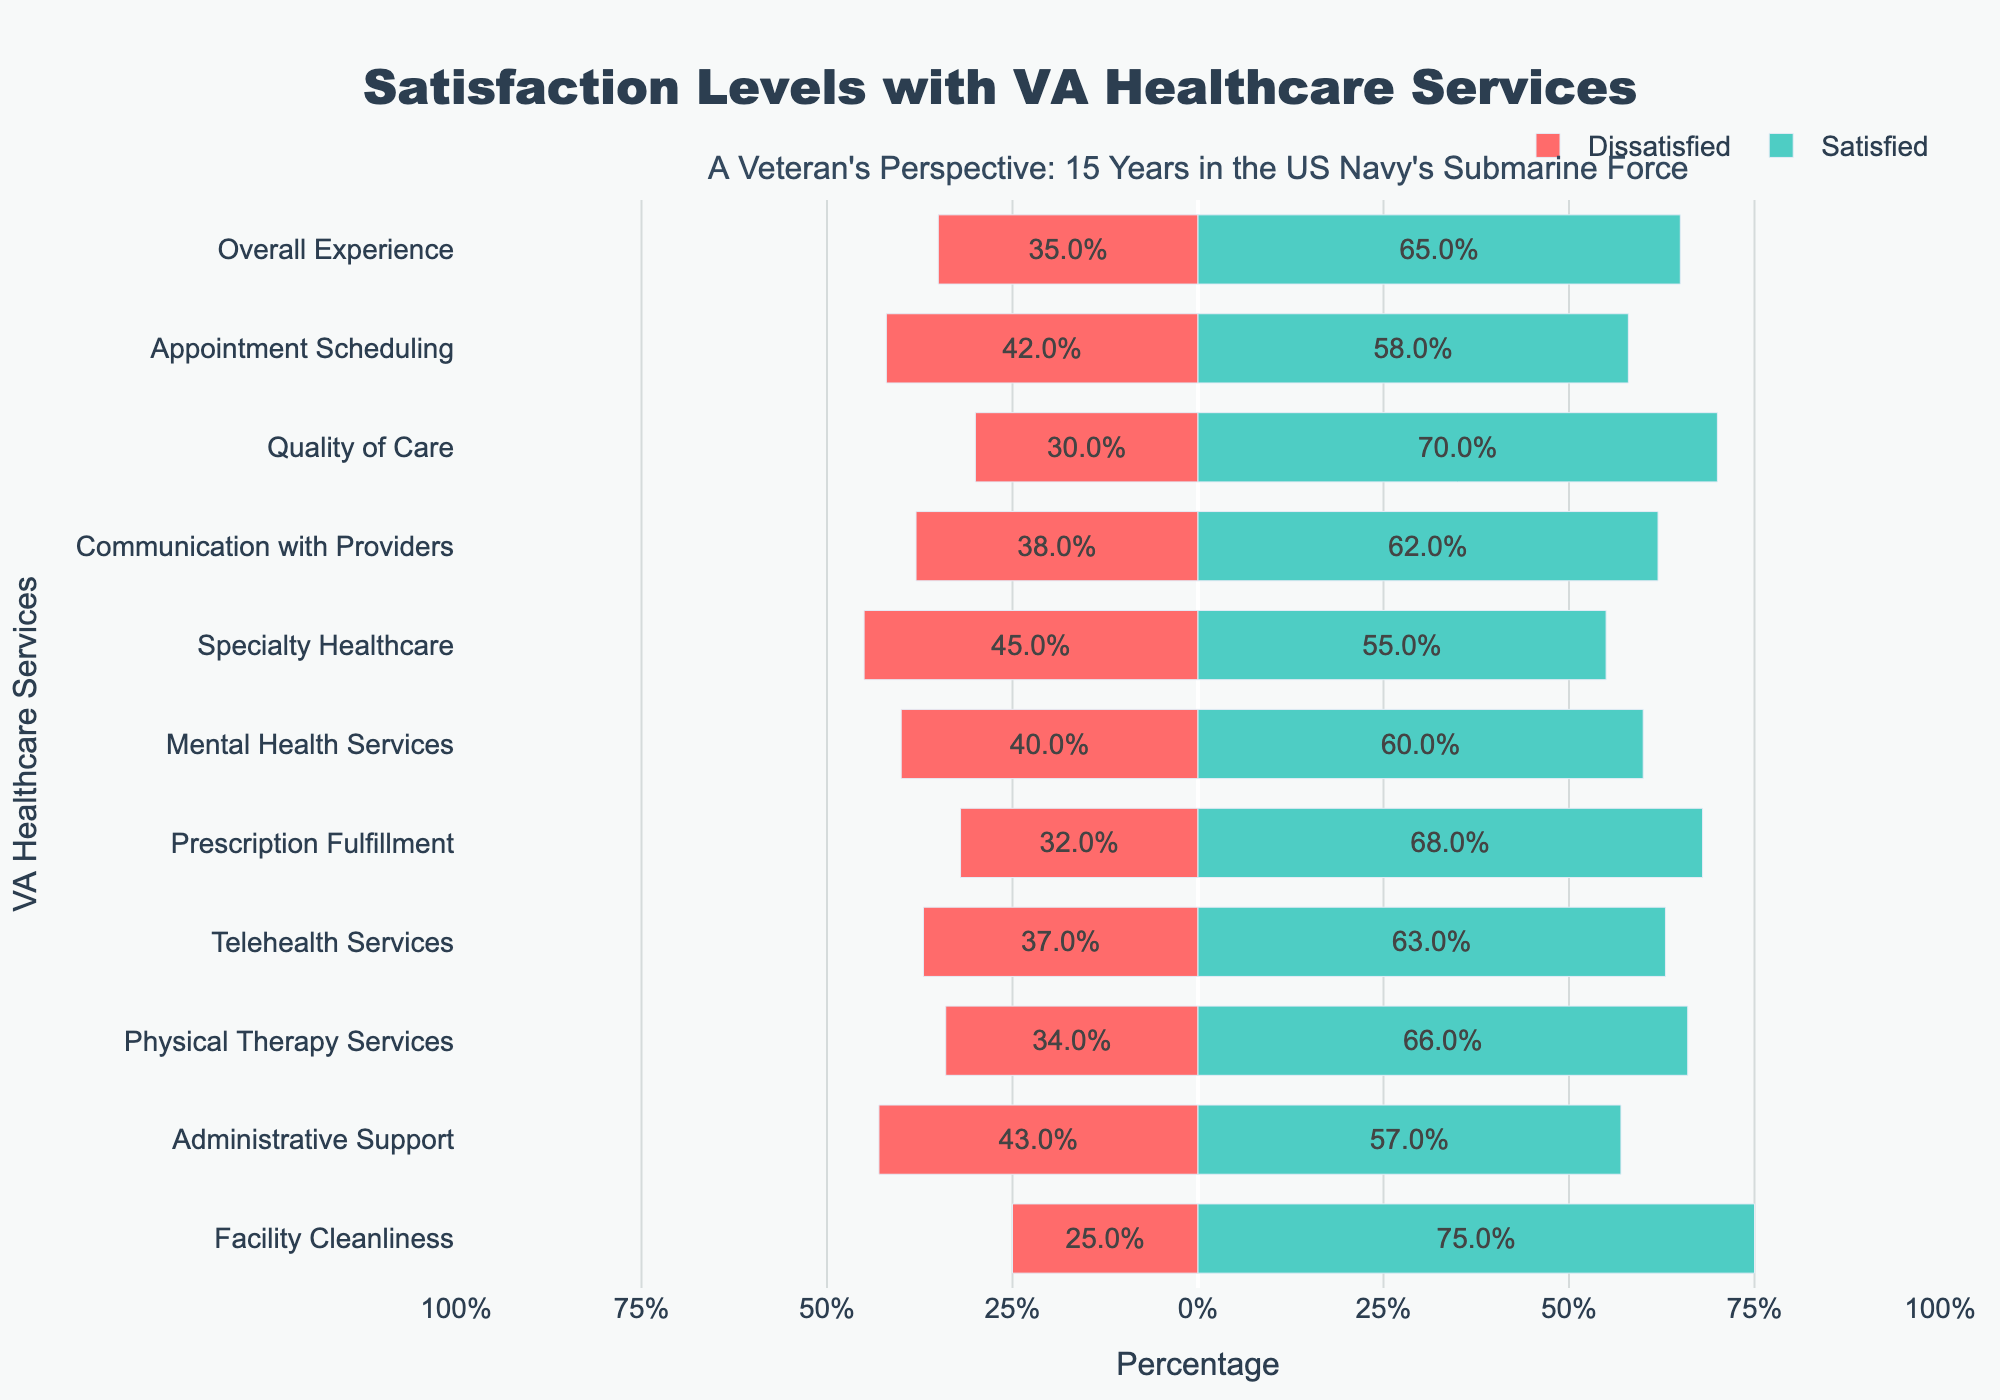Which category has the highest satisfaction level? The category with the highest satisfaction level is the one with the tallest green bar. "Facility Cleanliness" has the highest satisfaction percentage at 75%.
Answer: Facility Cleanliness How much higher is the satisfaction for "Quality of Care" compared to "Specialty Healthcare"? To find out how much higher the satisfaction is, subtract the Satisfied_Pct of "Specialty Healthcare" (55%) from "Quality of Care" (70%): 70% - 55% = 15%.
Answer: 15% Are there any categories where dissatisfaction is greater than satisfaction? Find categories where the red bar (Dissatisfied) is longer than the green bar (Satisfied). No categories have more dissatisfaction than satisfaction.
Answer: No What is the average satisfaction level across all categories? Sum the satisfaction percentages of all categories and divide by the number of categories (11): (65+58+70+62+55+60+68+63+66+57+75)/11 ≈ 63.
Answer: 63% Which category has a satisfaction percentage closest to the overall average satisfaction? The overall average satisfaction is 63%. Compare each category's satisfaction level to find the closest: "Telehealth Services" has a satisfaction percentage closest to 63%.
Answer: Telehealth Services What is the total percentage of veterans dissatisfied with "Appointment Scheduling" and "Mental Health Services"? Sum the dissatisfied percentages of "Appointment Scheduling" (42%) and "Mental Health Services" (40%): 42% + 40% = 82%.
Answer: 82% In which category do the satisfied and dissatisfied percentages add up to 100%? For each category, check if the sum of satisfied and dissatisfied percentages equals 100%. All categories fit this criterion.
Answer: All categories Which has higher satisfaction: "Administrative Support" or "Specialty Healthcare"? Compare the satisfaction percentages of "Administrative Support" (57%) and "Specialty Healthcare" (55%): "Administrative Support" has a higher satisfaction percentage.
Answer: Administrative Support How does the percentage of dissatisfied veterans for "Telehealth Services" compare to "Physical Therapy Services"? Compare the dissatisfied percentages of "Telehealth Services" (37%) and "Physical Therapy Services" (34%). "Telehealth Services" has a higher dissatisfaction percentage.
Answer: Telehealth Services 